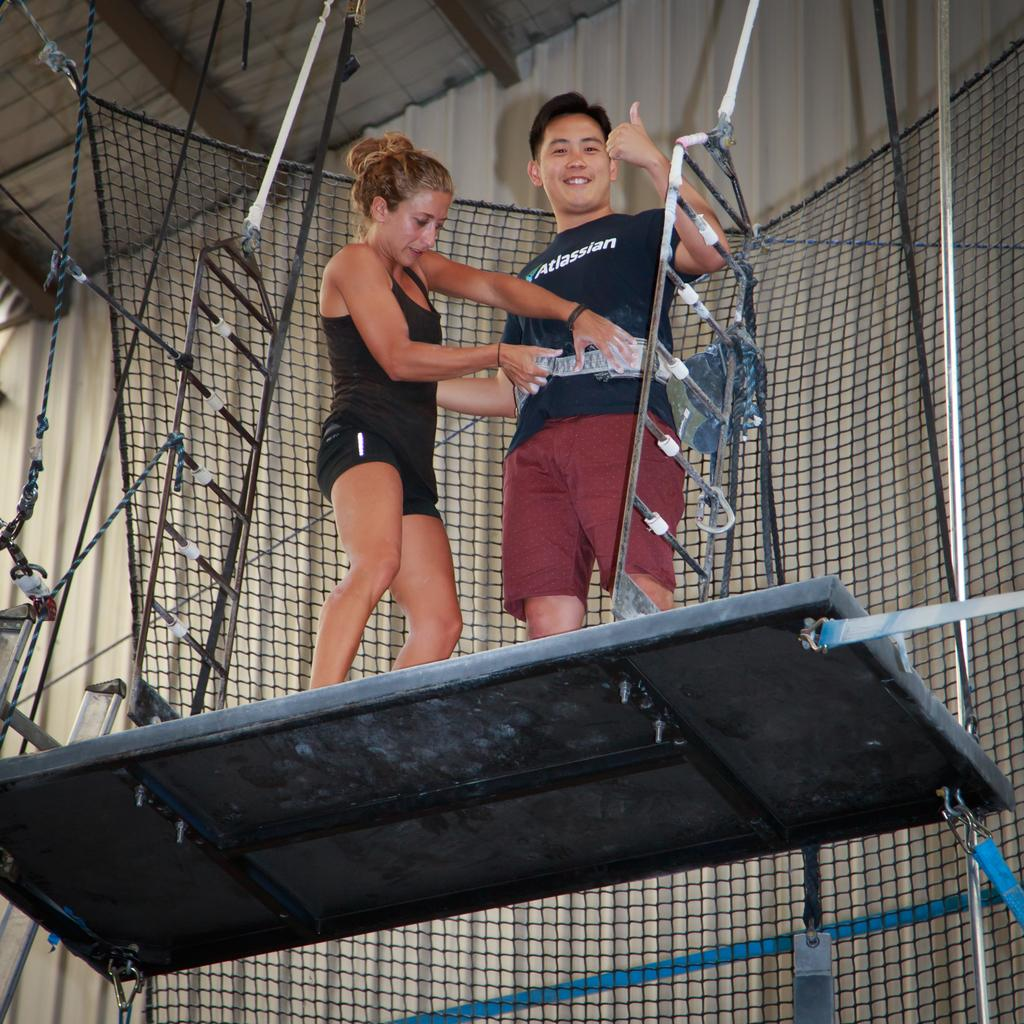How many people are in the image? There are two persons in the image. What are the two persons doing in the image? The two persons are standing on an object. What else can be seen in the image besides the two persons? There are other objects in the image. What type of object is visible in the image that might be used for catching or holding? There is a net visible in the image. What type of bone can be seen in the image? There is no bone present in the image. What are the two persons learning in the image? The provided facts do not mention any learning activity in the image. 